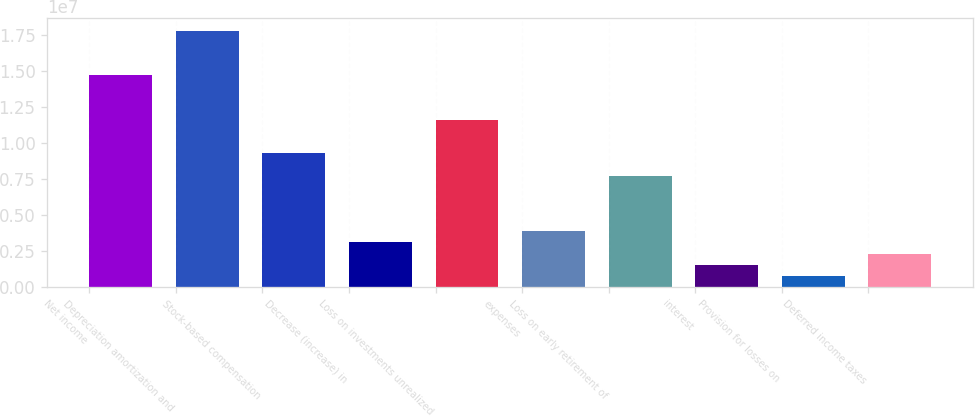Convert chart to OTSL. <chart><loc_0><loc_0><loc_500><loc_500><bar_chart><fcel>Net income<fcel>Depreciation amortization and<fcel>Stock-based compensation<fcel>Decrease (increase) in<fcel>Loss on investments unrealized<fcel>expenses<fcel>Loss on early retirement of<fcel>interest<fcel>Provision for losses on<fcel>Deferred income taxes<nl><fcel>1.47075e+07<fcel>1.78034e+07<fcel>9.28969e+06<fcel>3.09787e+06<fcel>1.16116e+07<fcel>3.87185e+06<fcel>7.74174e+06<fcel>1.54992e+06<fcel>775945<fcel>2.3239e+06<nl></chart> 